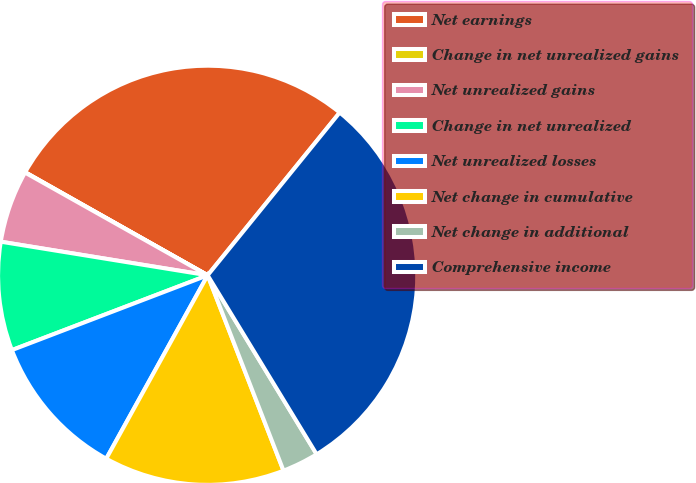Convert chart to OTSL. <chart><loc_0><loc_0><loc_500><loc_500><pie_chart><fcel>Net earnings<fcel>Change in net unrealized gains<fcel>Net unrealized gains<fcel>Change in net unrealized<fcel>Net unrealized losses<fcel>Net change in cumulative<fcel>Net change in additional<fcel>Comprehensive income<nl><fcel>27.66%<fcel>0.03%<fcel>5.59%<fcel>8.37%<fcel>11.15%<fcel>13.93%<fcel>2.81%<fcel>30.44%<nl></chart> 